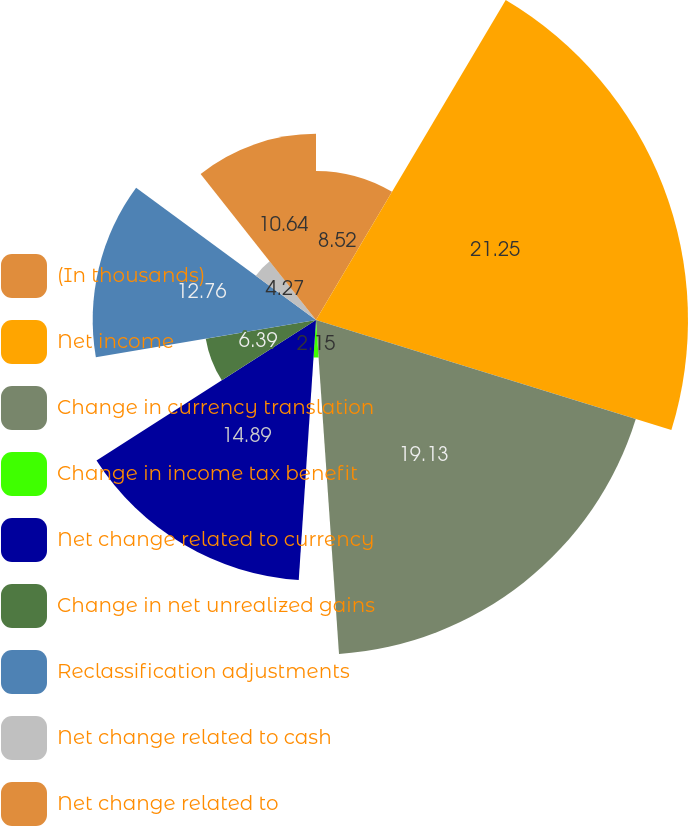<chart> <loc_0><loc_0><loc_500><loc_500><pie_chart><fcel>(In thousands)<fcel>Net income<fcel>Change in currency translation<fcel>Change in income tax benefit<fcel>Net change related to currency<fcel>Change in net unrealized gains<fcel>Reclassification adjustments<fcel>Net change related to cash<fcel>Net change related to<nl><fcel>8.52%<fcel>21.26%<fcel>19.13%<fcel>2.15%<fcel>14.89%<fcel>6.39%<fcel>12.76%<fcel>4.27%<fcel>10.64%<nl></chart> 